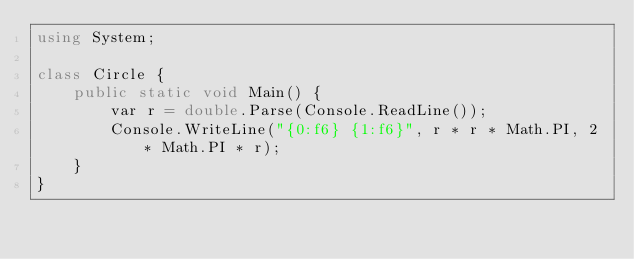<code> <loc_0><loc_0><loc_500><loc_500><_C#_>using System;

class Circle {
    public static void Main() {
        var r = double.Parse(Console.ReadLine());
        Console.WriteLine("{0:f6} {1:f6}", r * r * Math.PI, 2 * Math.PI * r);
    }
}
</code> 